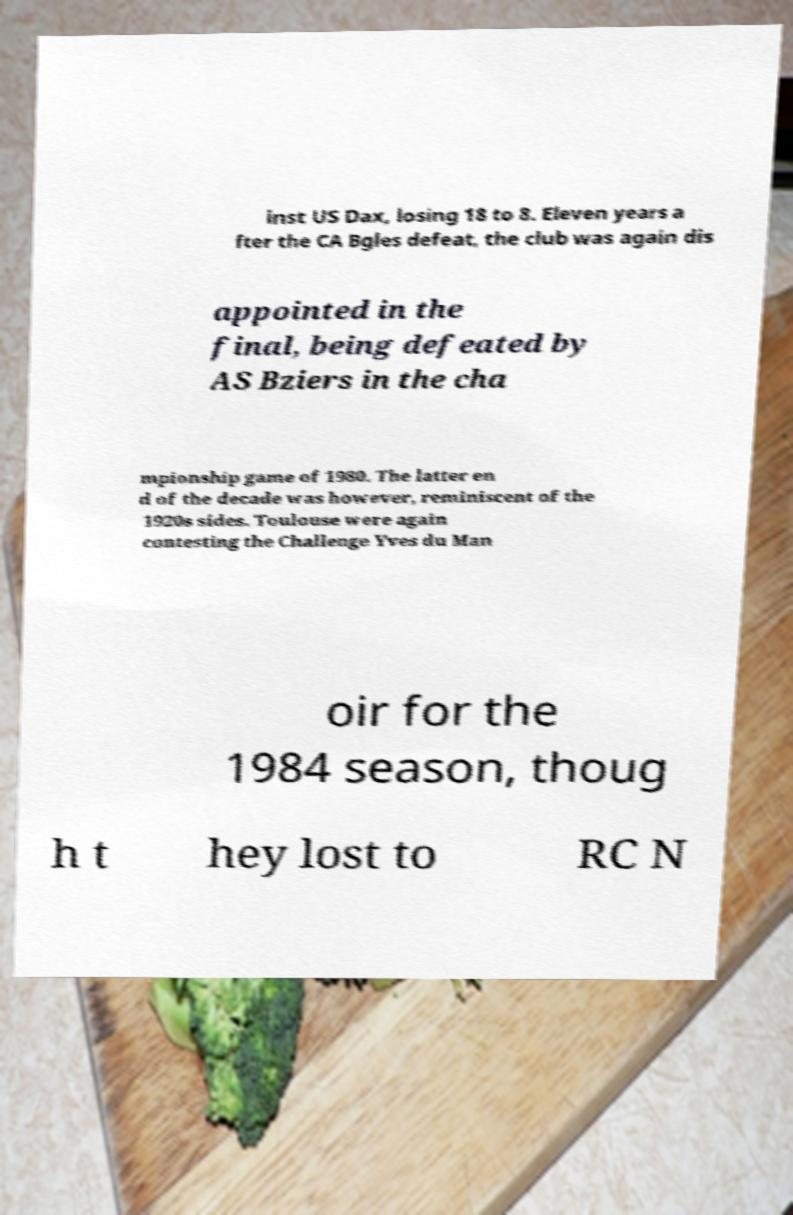There's text embedded in this image that I need extracted. Can you transcribe it verbatim? inst US Dax, losing 18 to 8. Eleven years a fter the CA Bgles defeat, the club was again dis appointed in the final, being defeated by AS Bziers in the cha mpionship game of 1980. The latter en d of the decade was however, reminiscent of the 1920s sides. Toulouse were again contesting the Challenge Yves du Man oir for the 1984 season, thoug h t hey lost to RC N 